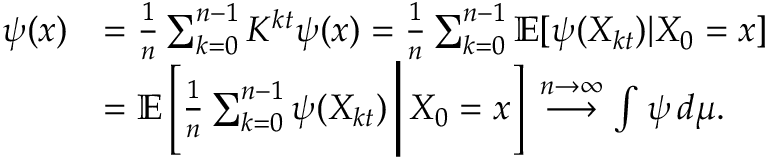<formula> <loc_0><loc_0><loc_500><loc_500>\begin{array} { r l } { \psi ( x ) } & { = \frac { 1 } { n } \sum _ { k = 0 } ^ { n - 1 } K ^ { k t } \psi ( x ) = \frac { 1 } { n } \sum _ { k = 0 } ^ { n - 1 } \mathbb { E } [ \psi ( X _ { k t } ) | X _ { 0 } = x ] } \\ & { = \mathbb { E } \left [ \frac { 1 } { n } \sum _ { k = 0 } ^ { n - 1 } \psi ( X _ { k t } ) \, \Big | \, X _ { 0 } = x \right ] \, \overset { n \to \infty } { \longrightarrow } \int \psi \, d \mu . } \end{array}</formula> 